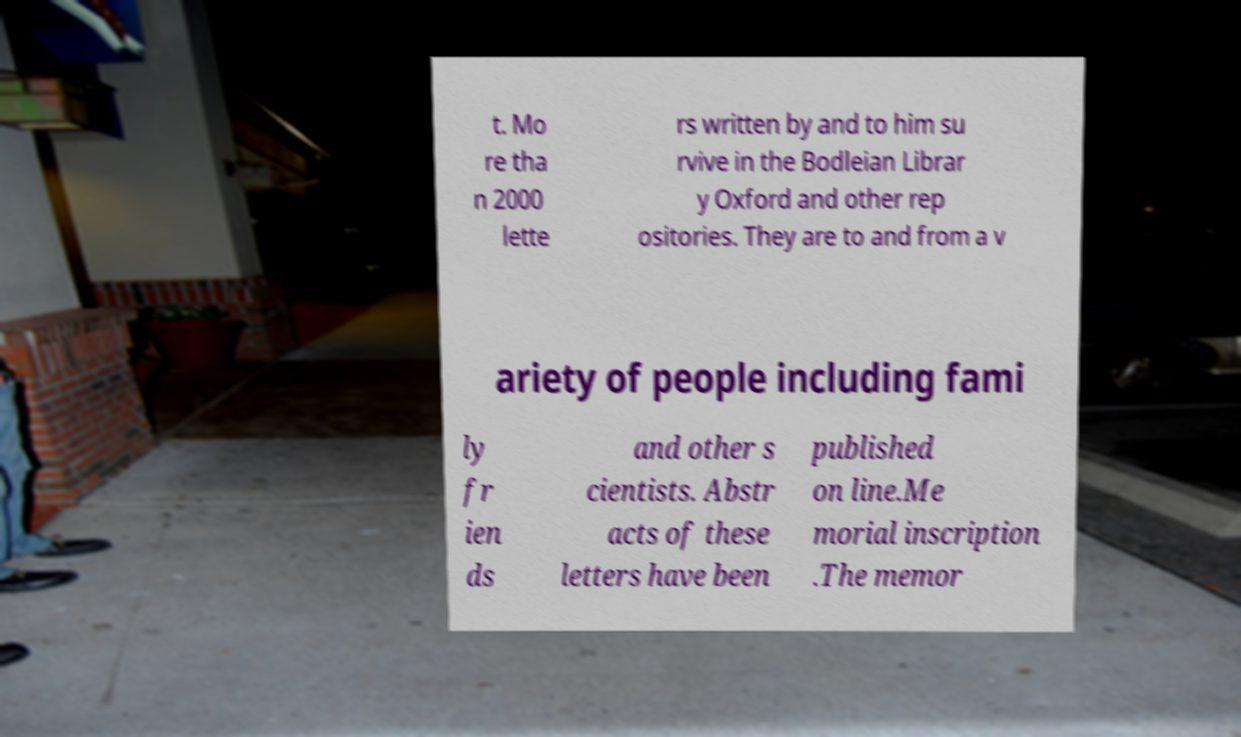Could you extract and type out the text from this image? t. Mo re tha n 2000 lette rs written by and to him su rvive in the Bodleian Librar y Oxford and other rep ositories. They are to and from a v ariety of people including fami ly fr ien ds and other s cientists. Abstr acts of these letters have been published on line.Me morial inscription .The memor 